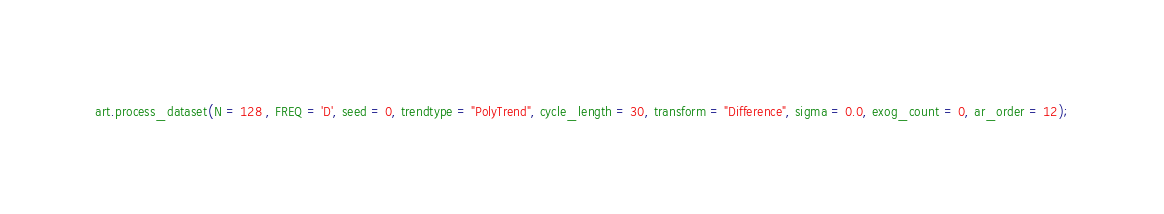Convert code to text. <code><loc_0><loc_0><loc_500><loc_500><_Python_>


art.process_dataset(N = 128 , FREQ = 'D', seed = 0, trendtype = "PolyTrend", cycle_length = 30, transform = "Difference", sigma = 0.0, exog_count = 0, ar_order = 12);</code> 